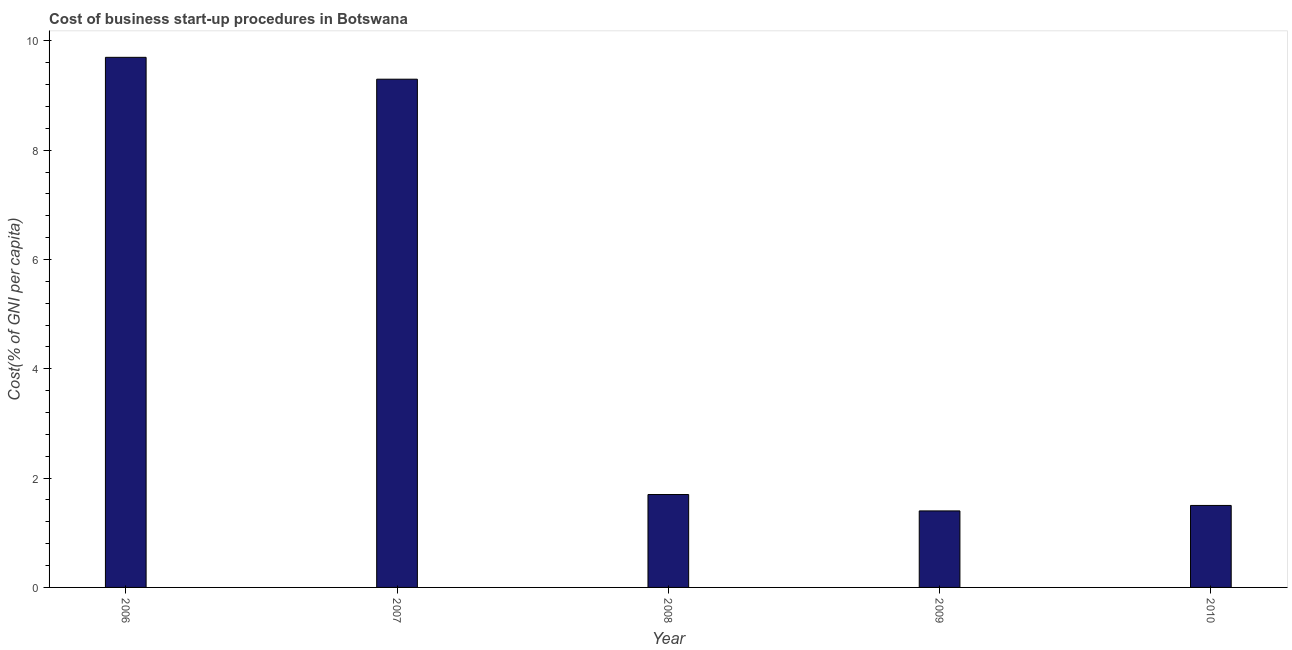What is the title of the graph?
Offer a terse response. Cost of business start-up procedures in Botswana. What is the label or title of the Y-axis?
Your answer should be very brief. Cost(% of GNI per capita). What is the cost of business startup procedures in 2006?
Provide a succinct answer. 9.7. Across all years, what is the minimum cost of business startup procedures?
Provide a short and direct response. 1.4. In which year was the cost of business startup procedures minimum?
Provide a succinct answer. 2009. What is the sum of the cost of business startup procedures?
Ensure brevity in your answer.  23.6. What is the difference between the cost of business startup procedures in 2007 and 2008?
Your answer should be very brief. 7.6. What is the average cost of business startup procedures per year?
Your response must be concise. 4.72. What is the ratio of the cost of business startup procedures in 2007 to that in 2009?
Provide a short and direct response. 6.64. Is the cost of business startup procedures in 2009 less than that in 2010?
Your response must be concise. Yes. Is the difference between the cost of business startup procedures in 2008 and 2009 greater than the difference between any two years?
Offer a terse response. No. Is the sum of the cost of business startup procedures in 2006 and 2008 greater than the maximum cost of business startup procedures across all years?
Make the answer very short. Yes. How many bars are there?
Offer a very short reply. 5. How many years are there in the graph?
Keep it short and to the point. 5. Are the values on the major ticks of Y-axis written in scientific E-notation?
Provide a short and direct response. No. What is the Cost(% of GNI per capita) in 2007?
Keep it short and to the point. 9.3. What is the Cost(% of GNI per capita) in 2009?
Keep it short and to the point. 1.4. What is the Cost(% of GNI per capita) in 2010?
Offer a terse response. 1.5. What is the difference between the Cost(% of GNI per capita) in 2007 and 2010?
Provide a short and direct response. 7.8. What is the difference between the Cost(% of GNI per capita) in 2008 and 2009?
Ensure brevity in your answer.  0.3. What is the difference between the Cost(% of GNI per capita) in 2009 and 2010?
Your response must be concise. -0.1. What is the ratio of the Cost(% of GNI per capita) in 2006 to that in 2007?
Your answer should be very brief. 1.04. What is the ratio of the Cost(% of GNI per capita) in 2006 to that in 2008?
Keep it short and to the point. 5.71. What is the ratio of the Cost(% of GNI per capita) in 2006 to that in 2009?
Provide a succinct answer. 6.93. What is the ratio of the Cost(% of GNI per capita) in 2006 to that in 2010?
Offer a very short reply. 6.47. What is the ratio of the Cost(% of GNI per capita) in 2007 to that in 2008?
Offer a very short reply. 5.47. What is the ratio of the Cost(% of GNI per capita) in 2007 to that in 2009?
Your response must be concise. 6.64. What is the ratio of the Cost(% of GNI per capita) in 2007 to that in 2010?
Give a very brief answer. 6.2. What is the ratio of the Cost(% of GNI per capita) in 2008 to that in 2009?
Make the answer very short. 1.21. What is the ratio of the Cost(% of GNI per capita) in 2008 to that in 2010?
Provide a succinct answer. 1.13. What is the ratio of the Cost(% of GNI per capita) in 2009 to that in 2010?
Provide a succinct answer. 0.93. 